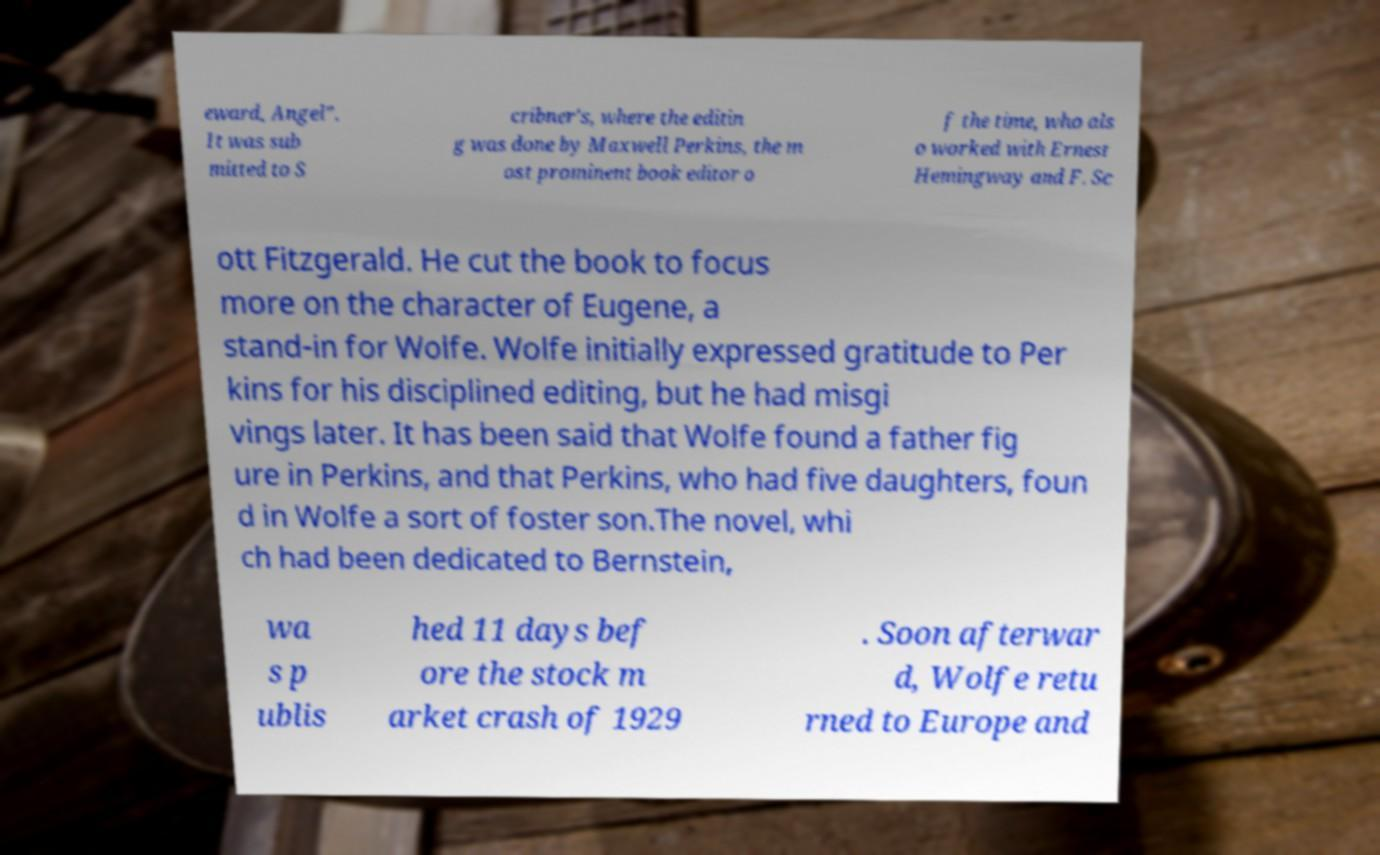Could you assist in decoding the text presented in this image and type it out clearly? eward, Angel". It was sub mitted to S cribner's, where the editin g was done by Maxwell Perkins, the m ost prominent book editor o f the time, who als o worked with Ernest Hemingway and F. Sc ott Fitzgerald. He cut the book to focus more on the character of Eugene, a stand-in for Wolfe. Wolfe initially expressed gratitude to Per kins for his disciplined editing, but he had misgi vings later. It has been said that Wolfe found a father fig ure in Perkins, and that Perkins, who had five daughters, foun d in Wolfe a sort of foster son.The novel, whi ch had been dedicated to Bernstein, wa s p ublis hed 11 days bef ore the stock m arket crash of 1929 . Soon afterwar d, Wolfe retu rned to Europe and 